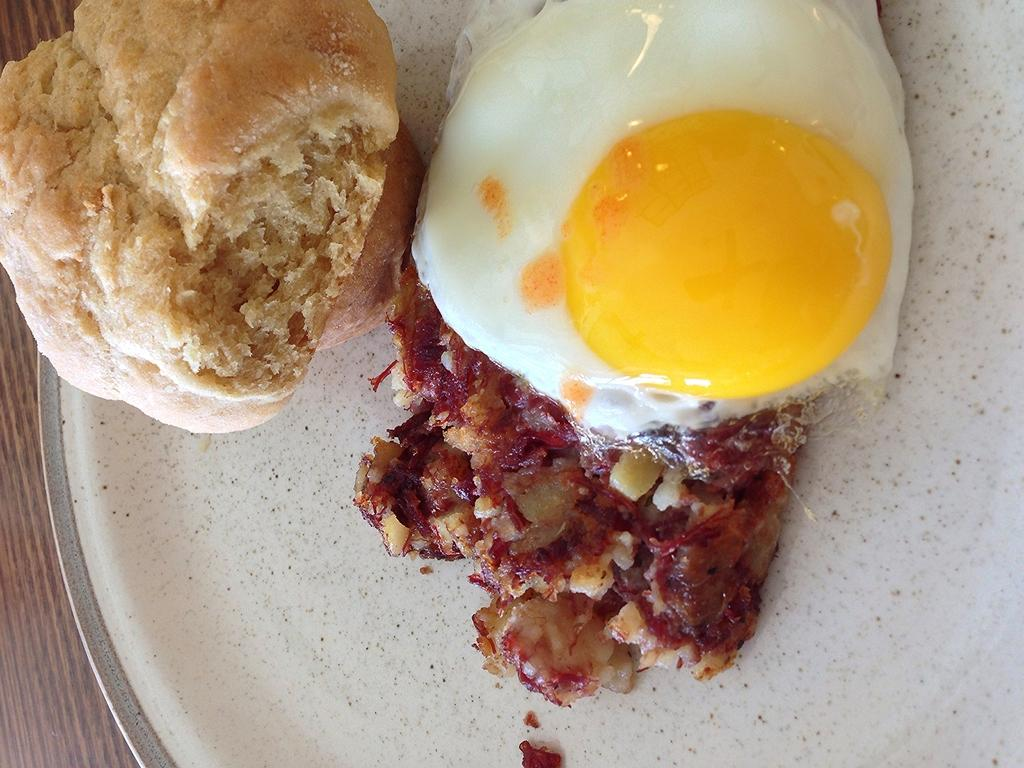What is on the plate that is visible in the image? Food items are present on the plate. Where is the plate located in the image? The plate is placed on a wooden surface. How is the fuel distributed among the vehicles in the image? There are no vehicles or fuel present in the image; it only contains a plate with food items on a wooden surface. 